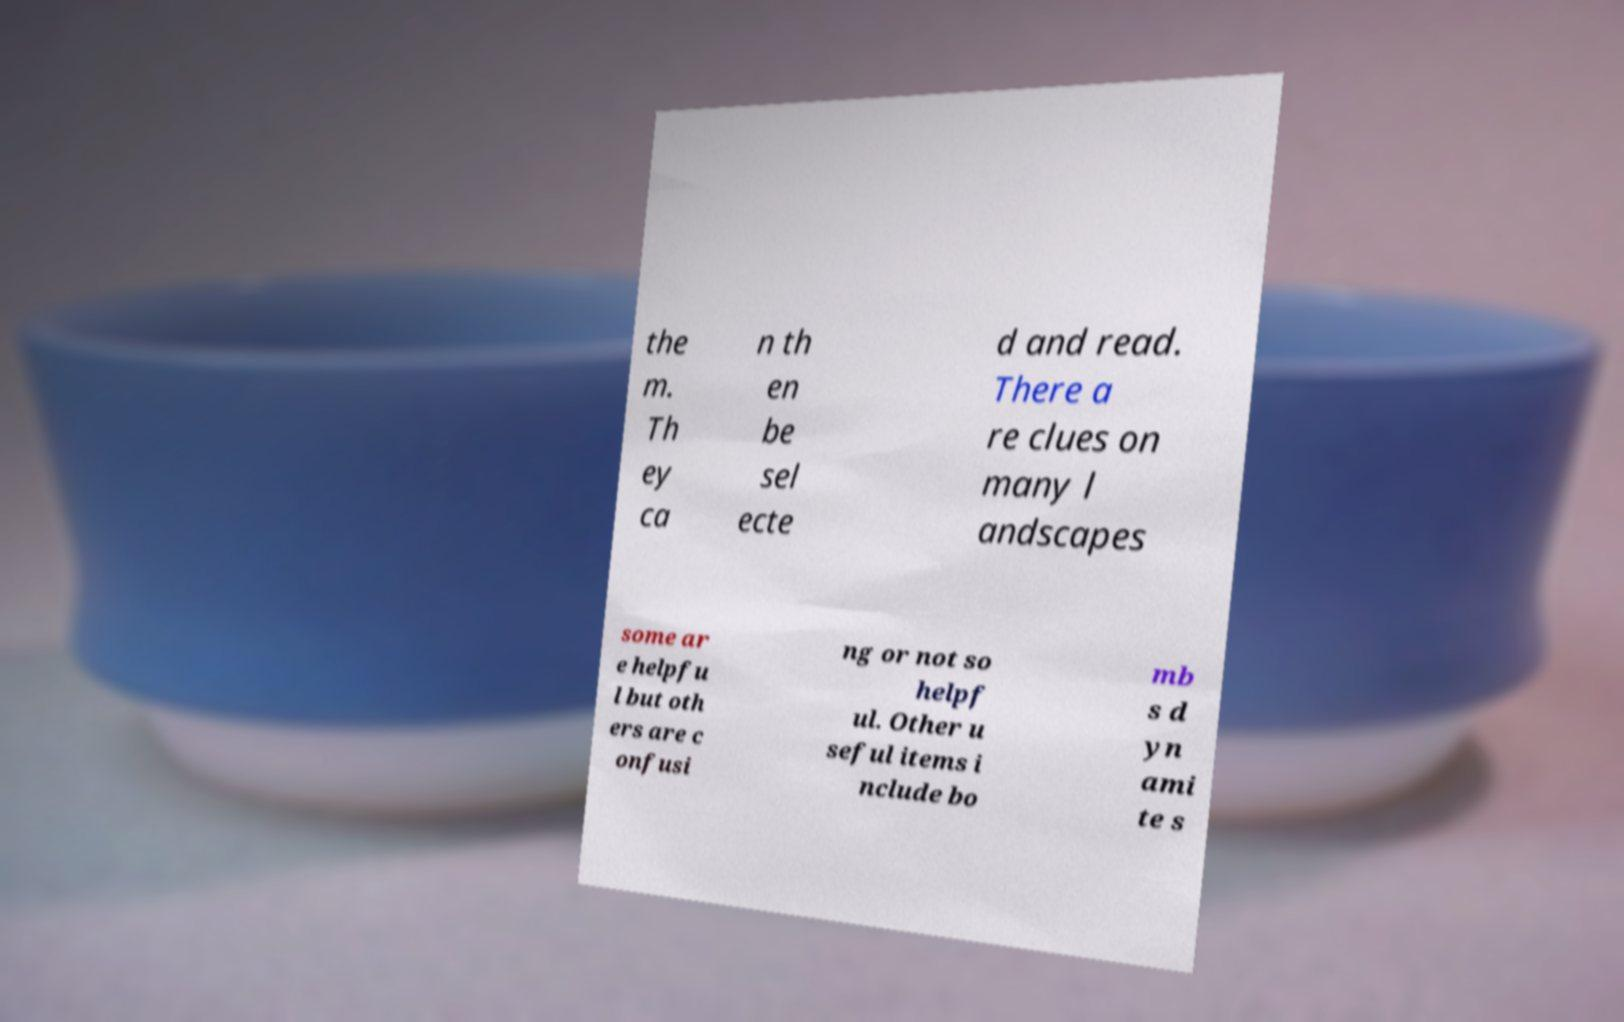I need the written content from this picture converted into text. Can you do that? the m. Th ey ca n th en be sel ecte d and read. There a re clues on many l andscapes some ar e helpfu l but oth ers are c onfusi ng or not so helpf ul. Other u seful items i nclude bo mb s d yn ami te s 